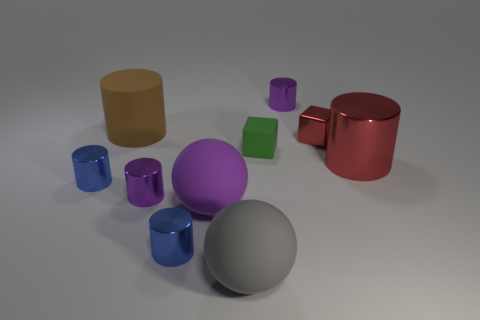What number of purple balls have the same material as the small red thing?
Keep it short and to the point. 0. How many objects are either tiny purple metallic things or blue things?
Provide a succinct answer. 4. Is there a tiny shiny cube that is in front of the big matte sphere that is left of the large gray ball?
Your answer should be very brief. No. Is the number of large red metallic objects left of the small green rubber object greater than the number of purple rubber balls that are on the left side of the brown cylinder?
Your response must be concise. No. What is the material of the large cylinder that is the same color as the tiny metal cube?
Your answer should be compact. Metal. How many big metal things are the same color as the metal cube?
Make the answer very short. 1. There is a metallic thing behind the large brown cylinder; is it the same color as the large cylinder that is left of the tiny green rubber block?
Offer a terse response. No. Are there any green matte things to the right of the large gray matte sphere?
Your answer should be very brief. Yes. What is the large gray object made of?
Offer a terse response. Rubber. The purple metal thing that is behind the tiny red object has what shape?
Your answer should be compact. Cylinder. 